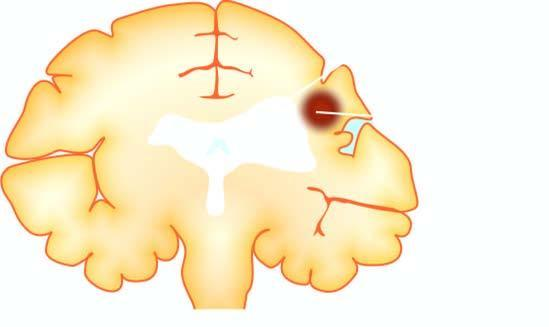s there shrinkage of scarred area with ipsilateral ventricular dilatation?
Answer the question using a single word or phrase. Yes 